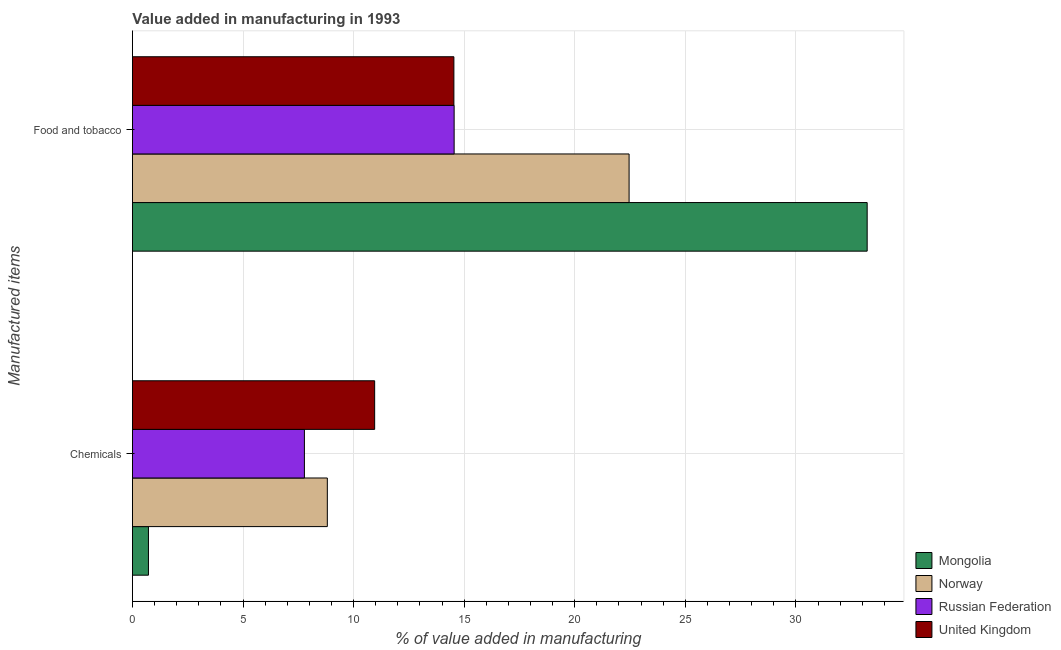How many different coloured bars are there?
Provide a short and direct response. 4. Are the number of bars on each tick of the Y-axis equal?
Your answer should be very brief. Yes. How many bars are there on the 2nd tick from the top?
Keep it short and to the point. 4. What is the label of the 2nd group of bars from the top?
Offer a terse response. Chemicals. What is the value added by manufacturing food and tobacco in Mongolia?
Offer a terse response. 33.22. Across all countries, what is the maximum value added by  manufacturing chemicals?
Offer a terse response. 10.95. Across all countries, what is the minimum value added by manufacturing food and tobacco?
Ensure brevity in your answer.  14.54. What is the total value added by  manufacturing chemicals in the graph?
Offer a very short reply. 28.27. What is the difference between the value added by manufacturing food and tobacco in Mongolia and that in Norway?
Offer a terse response. 10.77. What is the difference between the value added by  manufacturing chemicals in Mongolia and the value added by manufacturing food and tobacco in United Kingdom?
Ensure brevity in your answer.  -13.81. What is the average value added by manufacturing food and tobacco per country?
Your answer should be very brief. 21.19. What is the difference between the value added by manufacturing food and tobacco and value added by  manufacturing chemicals in Russian Federation?
Give a very brief answer. 6.77. What is the ratio of the value added by manufacturing food and tobacco in Norway to that in United Kingdom?
Make the answer very short. 1.55. Is the value added by  manufacturing chemicals in Mongolia less than that in United Kingdom?
Your answer should be compact. Yes. What does the 3rd bar from the bottom in Food and tobacco represents?
Provide a short and direct response. Russian Federation. How many bars are there?
Ensure brevity in your answer.  8. How many countries are there in the graph?
Give a very brief answer. 4. What is the difference between two consecutive major ticks on the X-axis?
Provide a succinct answer. 5. Are the values on the major ticks of X-axis written in scientific E-notation?
Ensure brevity in your answer.  No. Does the graph contain grids?
Offer a terse response. Yes. How are the legend labels stacked?
Provide a succinct answer. Vertical. What is the title of the graph?
Give a very brief answer. Value added in manufacturing in 1993. Does "Panama" appear as one of the legend labels in the graph?
Your answer should be compact. No. What is the label or title of the X-axis?
Offer a terse response. % of value added in manufacturing. What is the label or title of the Y-axis?
Your response must be concise. Manufactured items. What is the % of value added in manufacturing of Mongolia in Chemicals?
Provide a succinct answer. 0.72. What is the % of value added in manufacturing of Norway in Chemicals?
Your response must be concise. 8.81. What is the % of value added in manufacturing of Russian Federation in Chemicals?
Keep it short and to the point. 7.78. What is the % of value added in manufacturing in United Kingdom in Chemicals?
Ensure brevity in your answer.  10.95. What is the % of value added in manufacturing in Mongolia in Food and tobacco?
Ensure brevity in your answer.  33.22. What is the % of value added in manufacturing in Norway in Food and tobacco?
Make the answer very short. 22.46. What is the % of value added in manufacturing of Russian Federation in Food and tobacco?
Keep it short and to the point. 14.55. What is the % of value added in manufacturing of United Kingdom in Food and tobacco?
Offer a very short reply. 14.54. Across all Manufactured items, what is the maximum % of value added in manufacturing of Mongolia?
Give a very brief answer. 33.22. Across all Manufactured items, what is the maximum % of value added in manufacturing of Norway?
Your answer should be very brief. 22.46. Across all Manufactured items, what is the maximum % of value added in manufacturing of Russian Federation?
Keep it short and to the point. 14.55. Across all Manufactured items, what is the maximum % of value added in manufacturing in United Kingdom?
Your answer should be very brief. 14.54. Across all Manufactured items, what is the minimum % of value added in manufacturing in Mongolia?
Your response must be concise. 0.72. Across all Manufactured items, what is the minimum % of value added in manufacturing of Norway?
Make the answer very short. 8.81. Across all Manufactured items, what is the minimum % of value added in manufacturing of Russian Federation?
Your answer should be compact. 7.78. Across all Manufactured items, what is the minimum % of value added in manufacturing in United Kingdom?
Provide a short and direct response. 10.95. What is the total % of value added in manufacturing in Mongolia in the graph?
Offer a terse response. 33.95. What is the total % of value added in manufacturing of Norway in the graph?
Give a very brief answer. 31.27. What is the total % of value added in manufacturing in Russian Federation in the graph?
Offer a very short reply. 22.32. What is the total % of value added in manufacturing of United Kingdom in the graph?
Your answer should be compact. 25.49. What is the difference between the % of value added in manufacturing of Mongolia in Chemicals and that in Food and tobacco?
Keep it short and to the point. -32.5. What is the difference between the % of value added in manufacturing of Norway in Chemicals and that in Food and tobacco?
Provide a succinct answer. -13.64. What is the difference between the % of value added in manufacturing in Russian Federation in Chemicals and that in Food and tobacco?
Ensure brevity in your answer.  -6.77. What is the difference between the % of value added in manufacturing in United Kingdom in Chemicals and that in Food and tobacco?
Offer a terse response. -3.58. What is the difference between the % of value added in manufacturing of Mongolia in Chemicals and the % of value added in manufacturing of Norway in Food and tobacco?
Keep it short and to the point. -21.73. What is the difference between the % of value added in manufacturing of Mongolia in Chemicals and the % of value added in manufacturing of Russian Federation in Food and tobacco?
Keep it short and to the point. -13.82. What is the difference between the % of value added in manufacturing of Mongolia in Chemicals and the % of value added in manufacturing of United Kingdom in Food and tobacco?
Offer a very short reply. -13.81. What is the difference between the % of value added in manufacturing of Norway in Chemicals and the % of value added in manufacturing of Russian Federation in Food and tobacco?
Provide a short and direct response. -5.73. What is the difference between the % of value added in manufacturing of Norway in Chemicals and the % of value added in manufacturing of United Kingdom in Food and tobacco?
Your answer should be very brief. -5.72. What is the difference between the % of value added in manufacturing in Russian Federation in Chemicals and the % of value added in manufacturing in United Kingdom in Food and tobacco?
Your answer should be very brief. -6.76. What is the average % of value added in manufacturing of Mongolia per Manufactured items?
Make the answer very short. 16.97. What is the average % of value added in manufacturing of Norway per Manufactured items?
Make the answer very short. 15.63. What is the average % of value added in manufacturing in Russian Federation per Manufactured items?
Your answer should be very brief. 11.16. What is the average % of value added in manufacturing in United Kingdom per Manufactured items?
Make the answer very short. 12.74. What is the difference between the % of value added in manufacturing of Mongolia and % of value added in manufacturing of Norway in Chemicals?
Your answer should be compact. -8.09. What is the difference between the % of value added in manufacturing in Mongolia and % of value added in manufacturing in Russian Federation in Chemicals?
Offer a terse response. -7.05. What is the difference between the % of value added in manufacturing of Mongolia and % of value added in manufacturing of United Kingdom in Chemicals?
Your response must be concise. -10.23. What is the difference between the % of value added in manufacturing in Norway and % of value added in manufacturing in Russian Federation in Chemicals?
Ensure brevity in your answer.  1.04. What is the difference between the % of value added in manufacturing in Norway and % of value added in manufacturing in United Kingdom in Chemicals?
Make the answer very short. -2.14. What is the difference between the % of value added in manufacturing in Russian Federation and % of value added in manufacturing in United Kingdom in Chemicals?
Give a very brief answer. -3.18. What is the difference between the % of value added in manufacturing in Mongolia and % of value added in manufacturing in Norway in Food and tobacco?
Your response must be concise. 10.77. What is the difference between the % of value added in manufacturing of Mongolia and % of value added in manufacturing of Russian Federation in Food and tobacco?
Provide a succinct answer. 18.68. What is the difference between the % of value added in manufacturing of Mongolia and % of value added in manufacturing of United Kingdom in Food and tobacco?
Offer a very short reply. 18.69. What is the difference between the % of value added in manufacturing of Norway and % of value added in manufacturing of Russian Federation in Food and tobacco?
Give a very brief answer. 7.91. What is the difference between the % of value added in manufacturing in Norway and % of value added in manufacturing in United Kingdom in Food and tobacco?
Ensure brevity in your answer.  7.92. What is the difference between the % of value added in manufacturing in Russian Federation and % of value added in manufacturing in United Kingdom in Food and tobacco?
Your answer should be compact. 0.01. What is the ratio of the % of value added in manufacturing of Mongolia in Chemicals to that in Food and tobacco?
Ensure brevity in your answer.  0.02. What is the ratio of the % of value added in manufacturing of Norway in Chemicals to that in Food and tobacco?
Ensure brevity in your answer.  0.39. What is the ratio of the % of value added in manufacturing in Russian Federation in Chemicals to that in Food and tobacco?
Provide a short and direct response. 0.53. What is the ratio of the % of value added in manufacturing in United Kingdom in Chemicals to that in Food and tobacco?
Your answer should be very brief. 0.75. What is the difference between the highest and the second highest % of value added in manufacturing in Mongolia?
Keep it short and to the point. 32.5. What is the difference between the highest and the second highest % of value added in manufacturing of Norway?
Your response must be concise. 13.64. What is the difference between the highest and the second highest % of value added in manufacturing in Russian Federation?
Your answer should be very brief. 6.77. What is the difference between the highest and the second highest % of value added in manufacturing of United Kingdom?
Offer a terse response. 3.58. What is the difference between the highest and the lowest % of value added in manufacturing in Mongolia?
Provide a short and direct response. 32.5. What is the difference between the highest and the lowest % of value added in manufacturing of Norway?
Offer a very short reply. 13.64. What is the difference between the highest and the lowest % of value added in manufacturing of Russian Federation?
Ensure brevity in your answer.  6.77. What is the difference between the highest and the lowest % of value added in manufacturing in United Kingdom?
Ensure brevity in your answer.  3.58. 